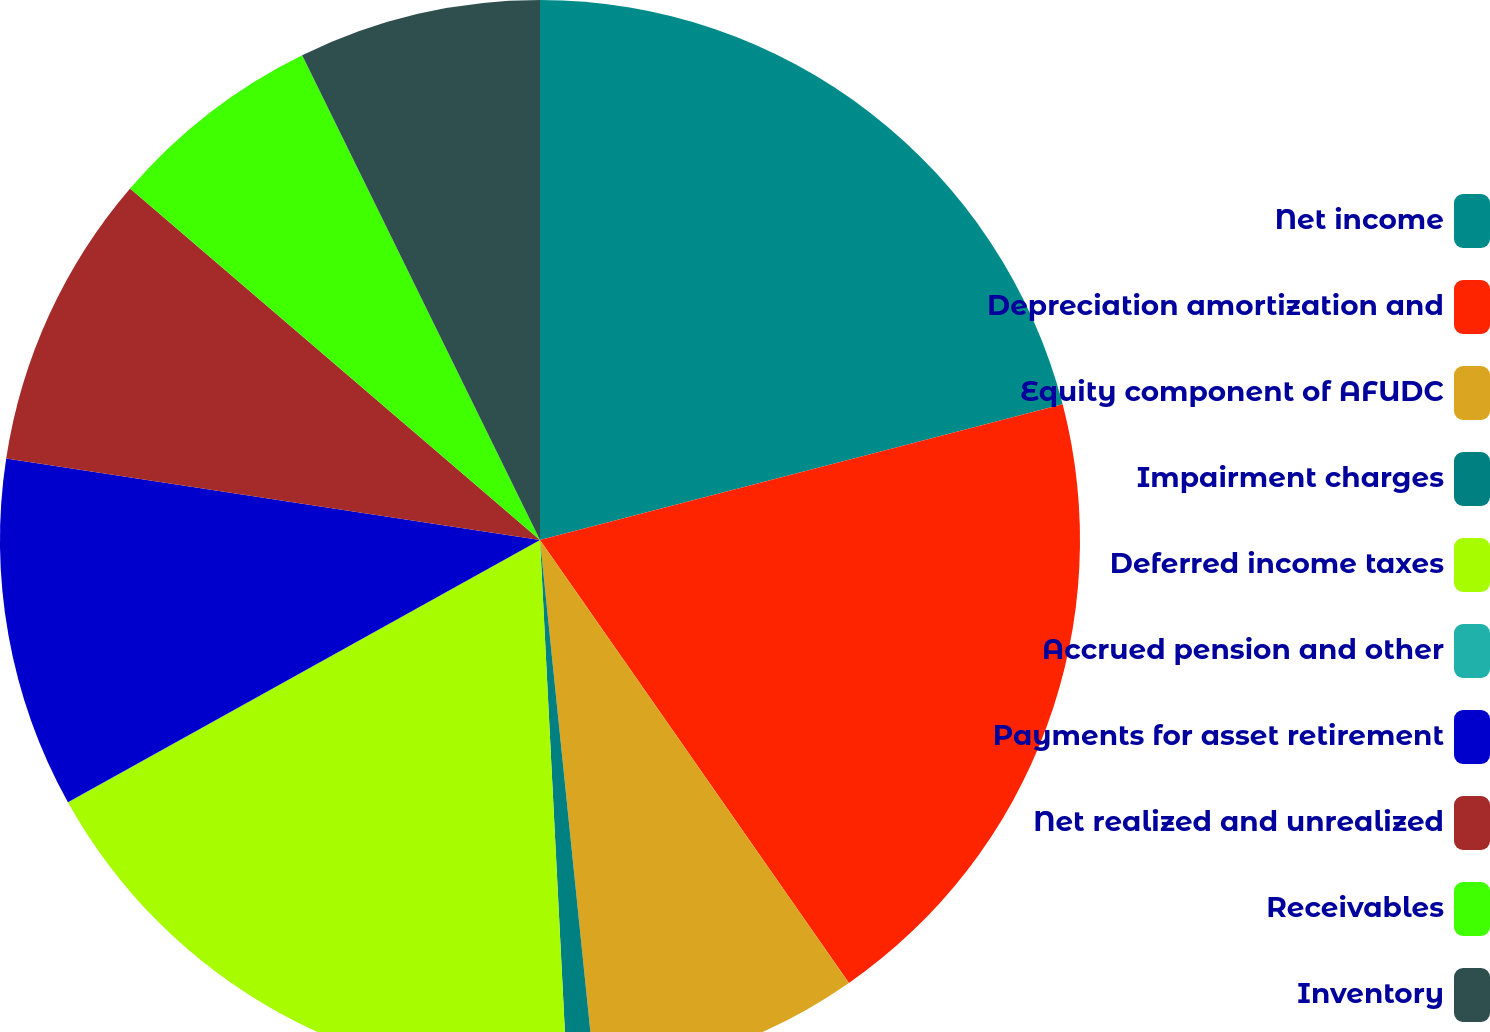Convert chart. <chart><loc_0><loc_0><loc_500><loc_500><pie_chart><fcel>Net income<fcel>Depreciation amortization and<fcel>Equity component of AFUDC<fcel>Impairment charges<fcel>Deferred income taxes<fcel>Accrued pension and other<fcel>Payments for asset retirement<fcel>Net realized and unrealized<fcel>Receivables<fcel>Inventory<nl><fcel>20.96%<fcel>19.35%<fcel>8.07%<fcel>0.82%<fcel>17.73%<fcel>0.01%<fcel>10.48%<fcel>8.87%<fcel>6.46%<fcel>7.26%<nl></chart> 